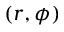Convert formula to latex. <formula><loc_0><loc_0><loc_500><loc_500>( r , \phi )</formula> 